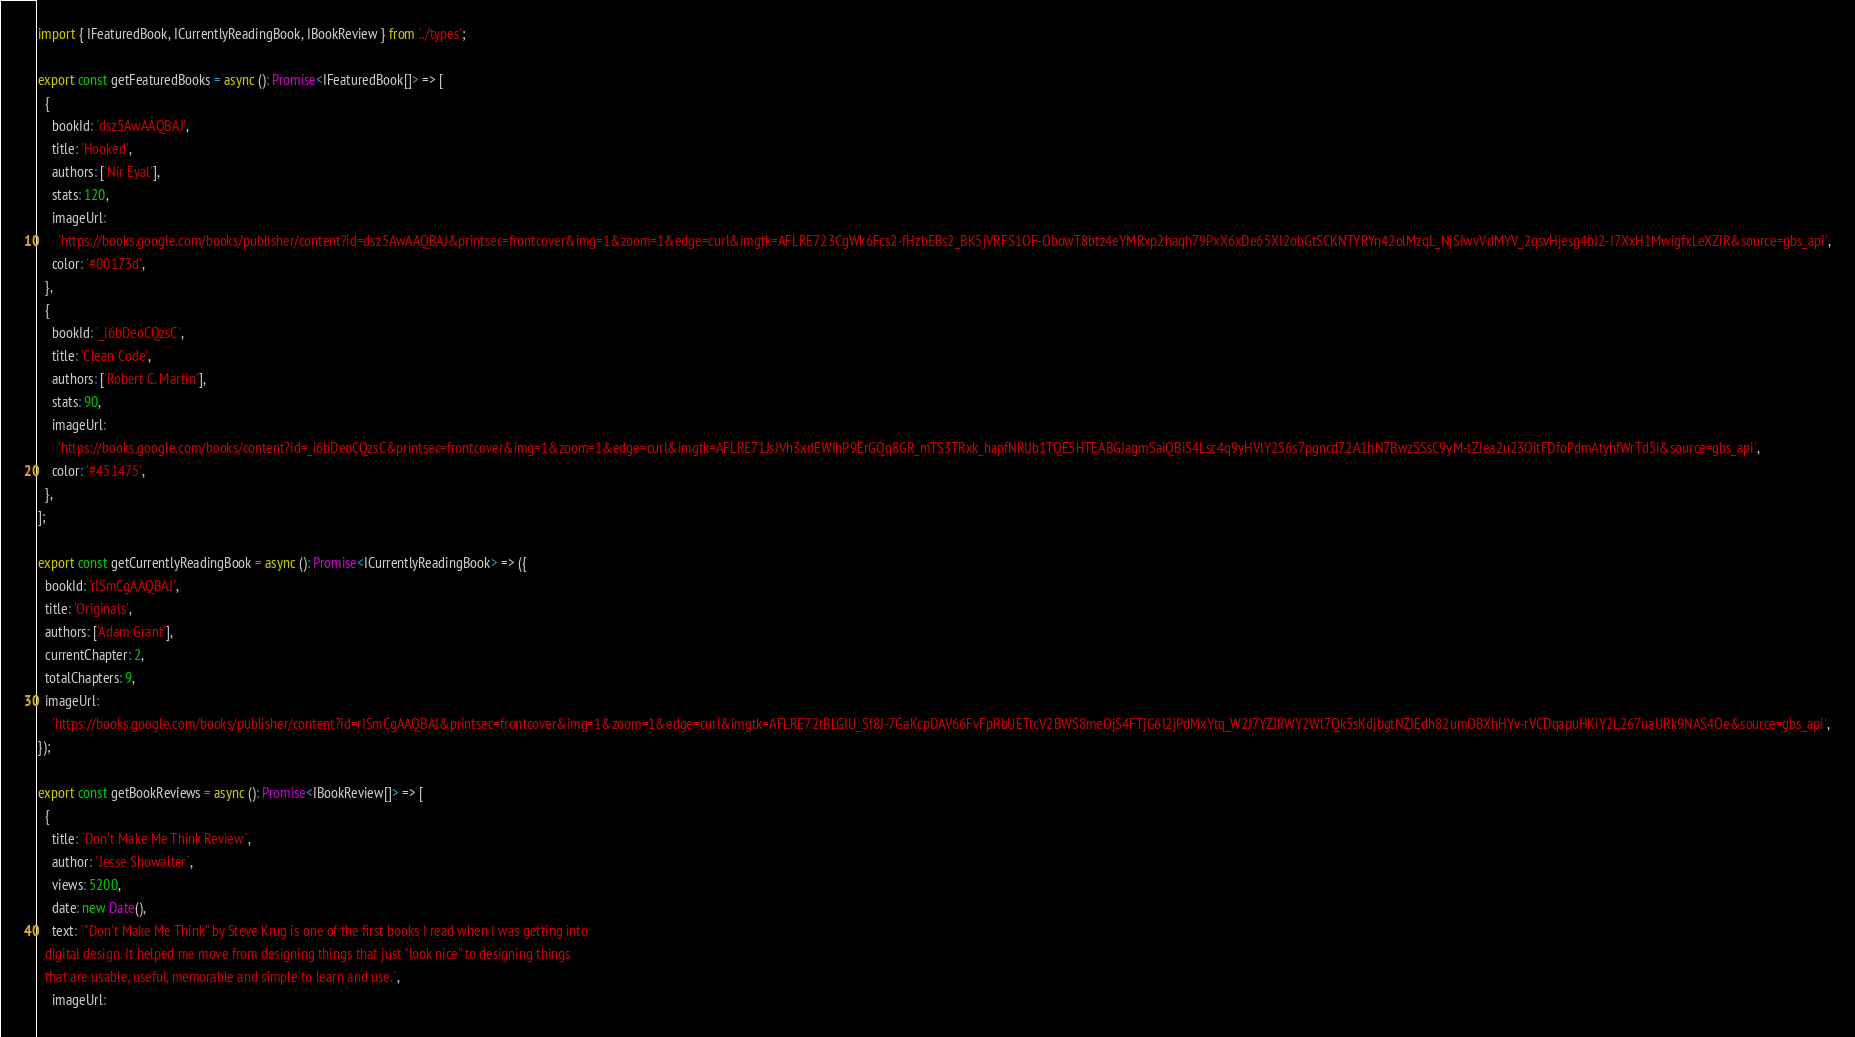Convert code to text. <code><loc_0><loc_0><loc_500><loc_500><_TypeScript_>import { IFeaturedBook, ICurrentlyReadingBook, IBookReview } from '../types';

export const getFeaturedBooks = async (): Promise<IFeaturedBook[]> => [
  {
    bookId: 'dsz5AwAAQBAJ',
    title: 'Hooked',
    authors: ['Nir Eyal'],
    stats: 120,
    imageUrl:
      'https://books.google.com/books/publisher/content?id=dsz5AwAAQBAJ&printsec=frontcover&img=1&zoom=1&edge=curl&imgtk=AFLRE723CgWk6Fcs2-fHzbEBs2_BK5jVRFS1OF-ObowT8btz4eYMRxp2haqh79PxX6xDe65XI2obGtSCKNTYRYn42olMzqL_NjSIwvVdMYV_2qsvHjesg4bJ2-I7XxH1MwigfxLeXZiR&source=gbs_api',
    color: '#00173d',
  },
  {
    bookId: '_i6bDeoCQzsC',
    title: 'Clean Code',
    authors: ['Robert C. Martin'],
    stats: 90,
    imageUrl:
      'https://books.google.com/books/content?id=_i6bDeoCQzsC&printsec=frontcover&img=1&zoom=1&edge=curl&imgtk=AFLRE71JsJVh3xdEWIhP9ErGQq8GR_mTS3TRxk_hapfNRlJb1TQE5HTEABGJagmSaiQBiS4Lsc4q9yHVlY2S6s7pgncd72A1hN7BwzSSsC9yM-tZIea2u23OitFDfoPdmAtyhfWrTd5i&source=gbs_api',
    color: '#451475',
  },
];

export const getCurrentlyReadingBook = async (): Promise<ICurrentlyReadingBook> => ({
  bookId: 'rISmCgAAQBAJ',
  title: 'Originals',
  authors: ['Adam Grant'],
  currentChapter: 2,
  totalChapters: 9,
  imageUrl:
    'https://books.google.com/books/publisher/content?id=rISmCgAAQBAJ&printsec=frontcover&img=1&zoom=1&edge=curl&imgtk=AFLRE72tBLGIU_Sf8J-7GaKcpDAV66FvFpRbUETtcV2BWS8meOjS4FTjG6I2jPdMxYtq_W2J7YZJRWY2Wl7Qk5sKdjbgtNZJEdh82umOBXhHYv-rVCDqapuHKiY2L267uaURk9NAS4Oe&source=gbs_api',
});

export const getBookReviews = async (): Promise<IBookReview[]> => [
  {
    title: `Don't Make Me Think Review`,
    author: `Jesse Showalter`,
    views: 5200,
    date: new Date(),
    text: `"Don't Make Me Think" by Steve Krug is one of the first books I read when I was getting into
  digital design. It helped me move from designing things that just "look nice" to designing things
  that are usable, useful, memorable and simple to learn and use.`,
    imageUrl:</code> 